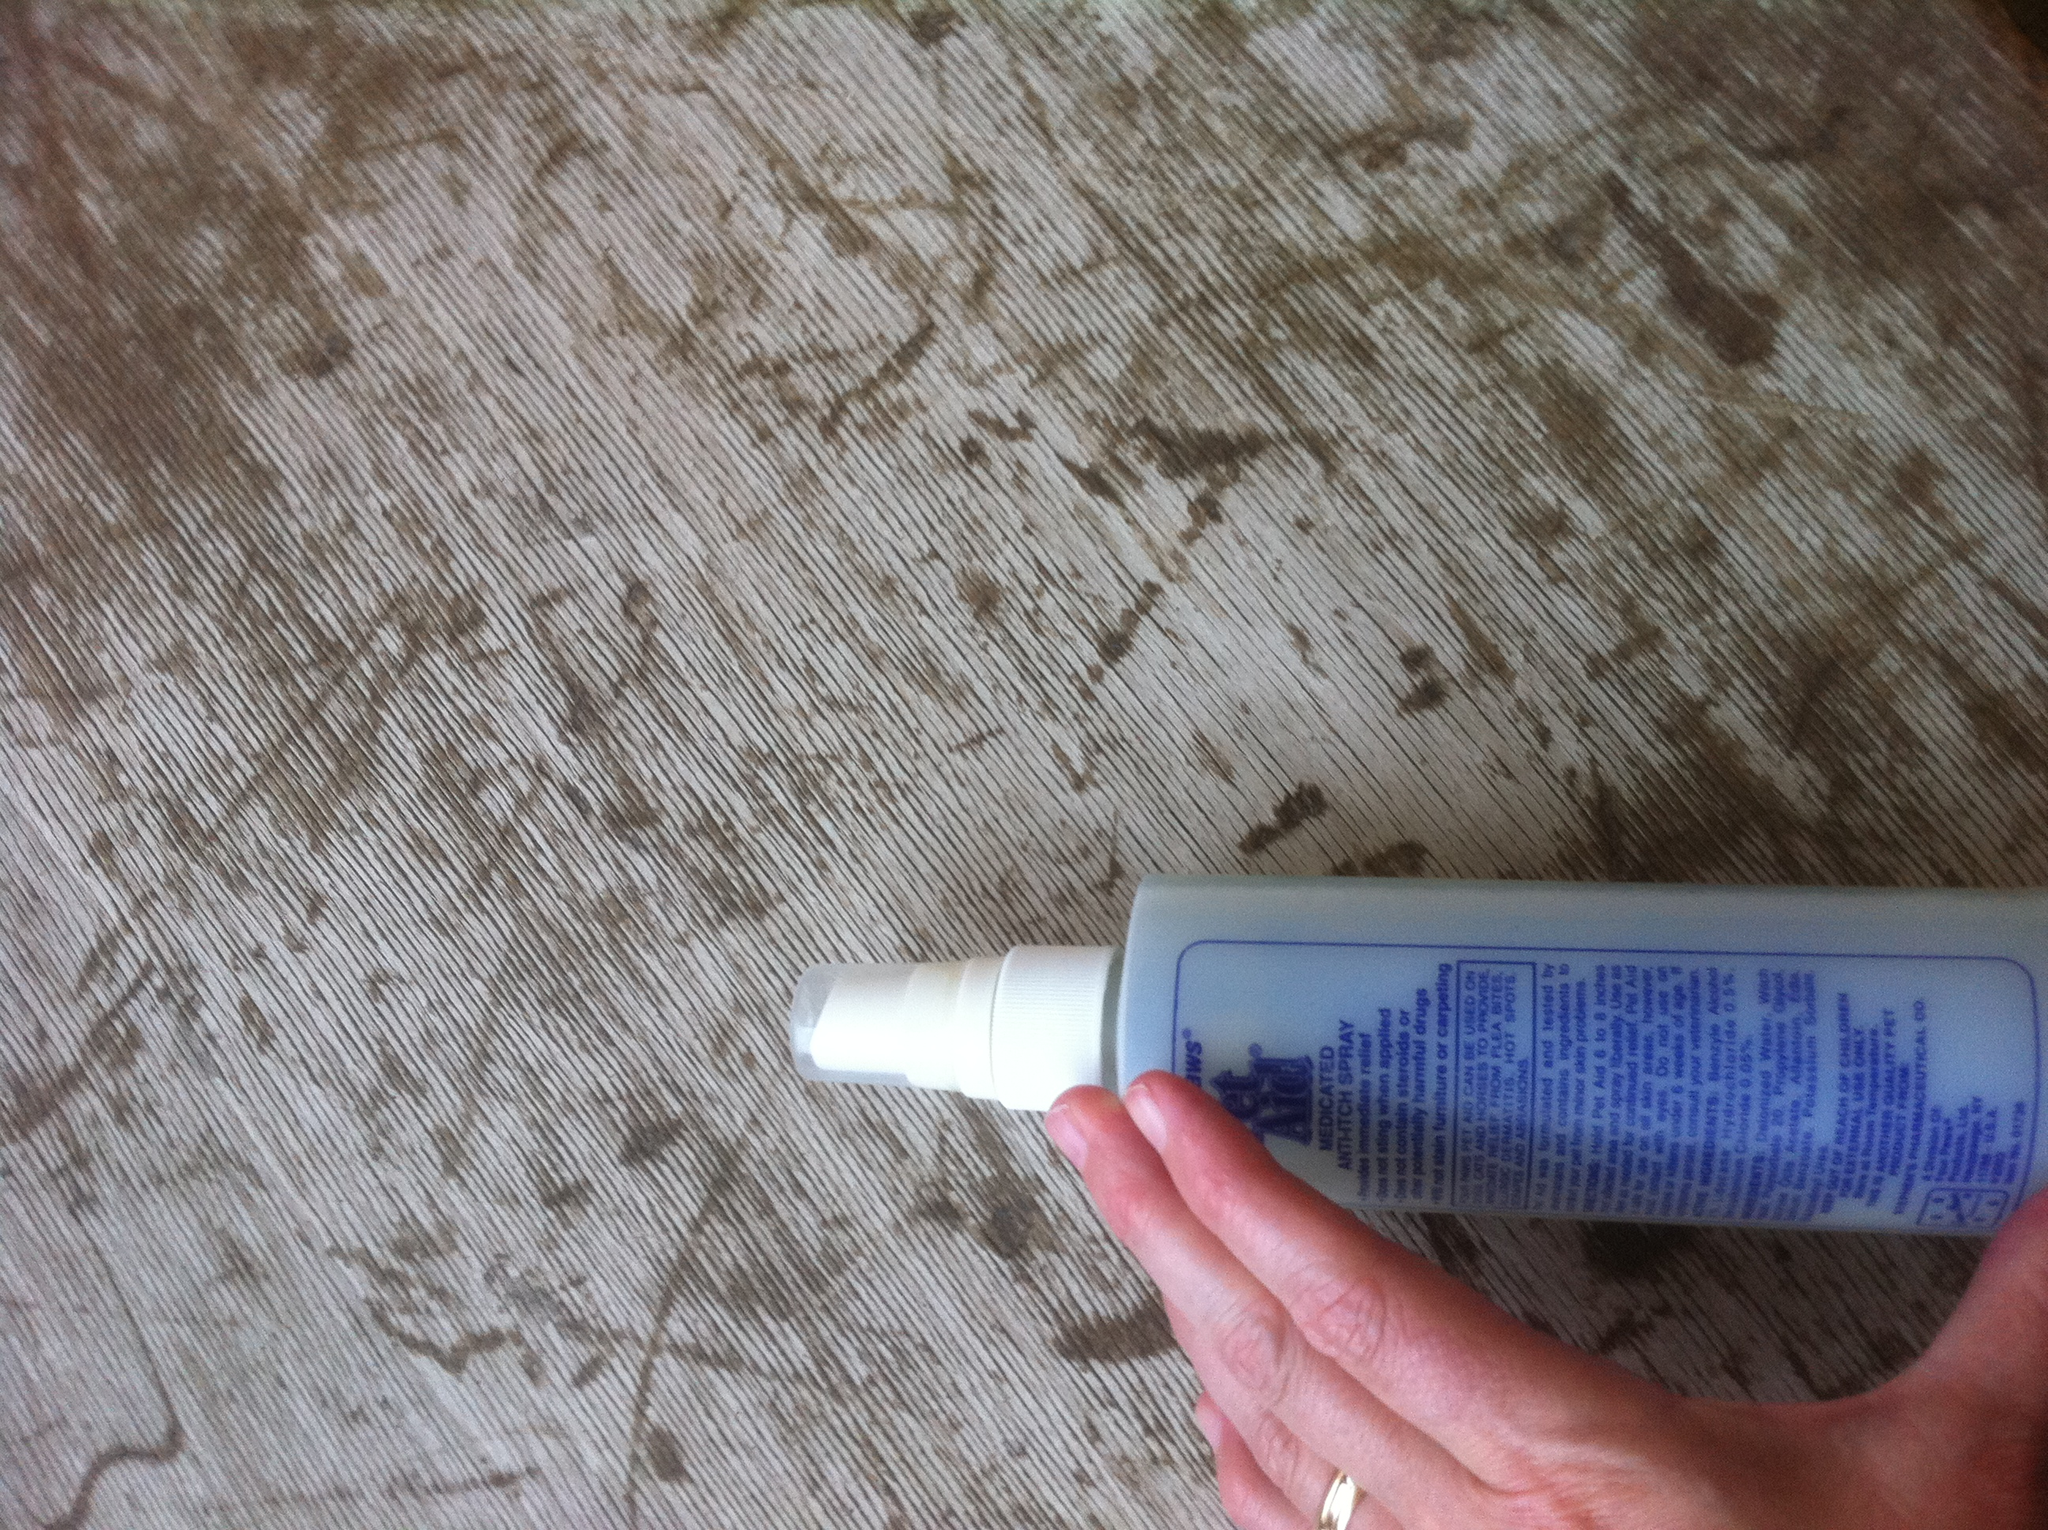What is the purpose of this dog product? This dog product is a spray designed to provide relief from various skin conditions such as itching, hot spots, and skin irritations. It can also be used for grooming purposes to keep your pet's coat healthy and clean. 